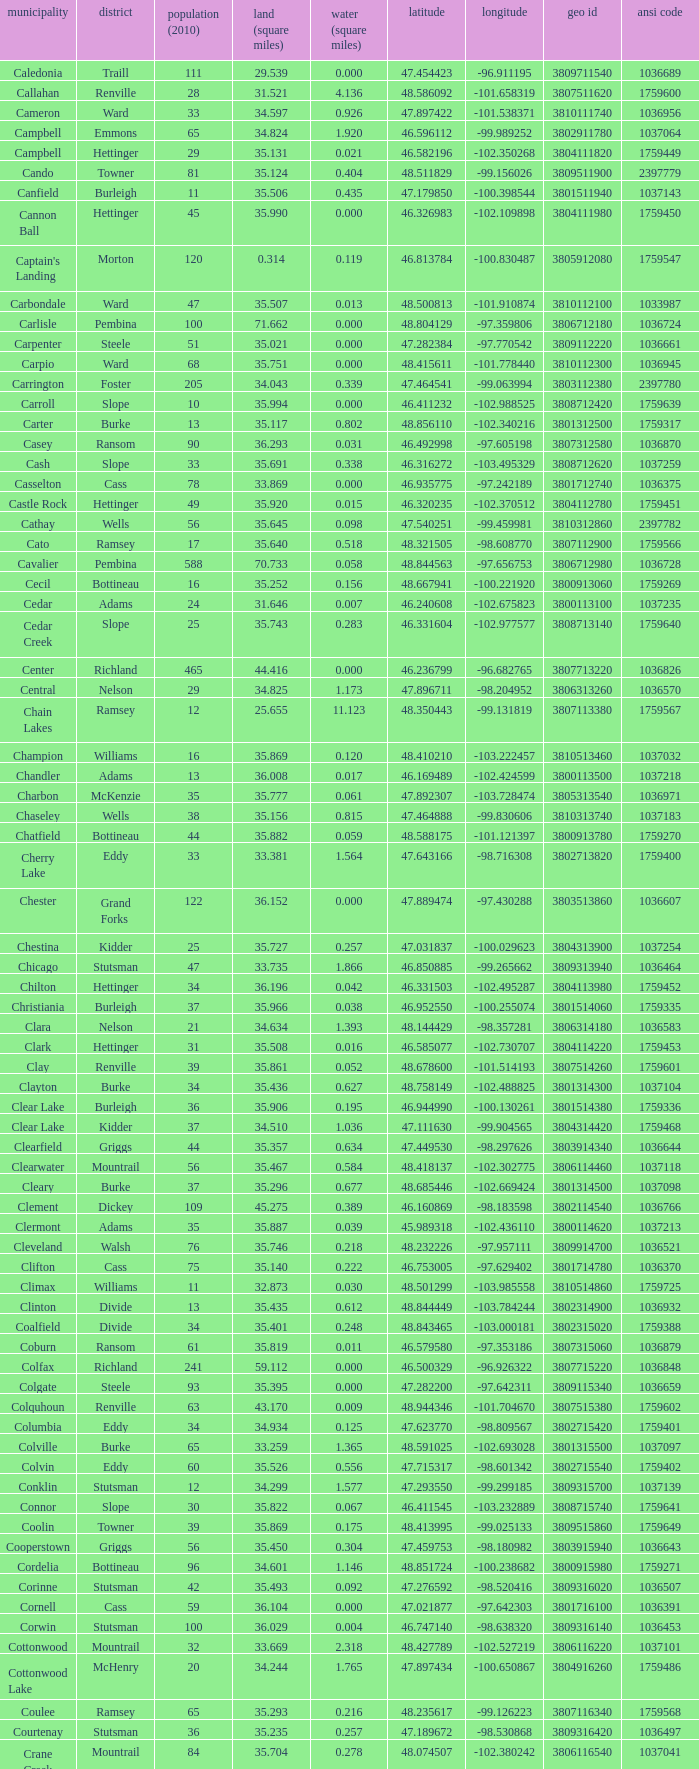What was the county with a latitude of 46.770977? Kidder. Could you parse the entire table? {'header': ['municipality', 'district', 'population (2010)', 'land (square miles)', 'water (square miles)', 'latitude', 'longitude', 'geo id', 'ansi code'], 'rows': [['Caledonia', 'Traill', '111', '29.539', '0.000', '47.454423', '-96.911195', '3809711540', '1036689'], ['Callahan', 'Renville', '28', '31.521', '4.136', '48.586092', '-101.658319', '3807511620', '1759600'], ['Cameron', 'Ward', '33', '34.597', '0.926', '47.897422', '-101.538371', '3810111740', '1036956'], ['Campbell', 'Emmons', '65', '34.824', '1.920', '46.596112', '-99.989252', '3802911780', '1037064'], ['Campbell', 'Hettinger', '29', '35.131', '0.021', '46.582196', '-102.350268', '3804111820', '1759449'], ['Cando', 'Towner', '81', '35.124', '0.404', '48.511829', '-99.156026', '3809511900', '2397779'], ['Canfield', 'Burleigh', '11', '35.506', '0.435', '47.179850', '-100.398544', '3801511940', '1037143'], ['Cannon Ball', 'Hettinger', '45', '35.990', '0.000', '46.326983', '-102.109898', '3804111980', '1759450'], ["Captain's Landing", 'Morton', '120', '0.314', '0.119', '46.813784', '-100.830487', '3805912080', '1759547'], ['Carbondale', 'Ward', '47', '35.507', '0.013', '48.500813', '-101.910874', '3810112100', '1033987'], ['Carlisle', 'Pembina', '100', '71.662', '0.000', '48.804129', '-97.359806', '3806712180', '1036724'], ['Carpenter', 'Steele', '51', '35.021', '0.000', '47.282384', '-97.770542', '3809112220', '1036661'], ['Carpio', 'Ward', '68', '35.751', '0.000', '48.415611', '-101.778440', '3810112300', '1036945'], ['Carrington', 'Foster', '205', '34.043', '0.339', '47.464541', '-99.063994', '3803112380', '2397780'], ['Carroll', 'Slope', '10', '35.994', '0.000', '46.411232', '-102.988525', '3808712420', '1759639'], ['Carter', 'Burke', '13', '35.117', '0.802', '48.856110', '-102.340216', '3801312500', '1759317'], ['Casey', 'Ransom', '90', '36.293', '0.031', '46.492998', '-97.605198', '3807312580', '1036870'], ['Cash', 'Slope', '33', '35.691', '0.338', '46.316272', '-103.495329', '3808712620', '1037259'], ['Casselton', 'Cass', '78', '33.869', '0.000', '46.935775', '-97.242189', '3801712740', '1036375'], ['Castle Rock', 'Hettinger', '49', '35.920', '0.015', '46.320235', '-102.370512', '3804112780', '1759451'], ['Cathay', 'Wells', '56', '35.645', '0.098', '47.540251', '-99.459981', '3810312860', '2397782'], ['Cato', 'Ramsey', '17', '35.640', '0.518', '48.321505', '-98.608770', '3807112900', '1759566'], ['Cavalier', 'Pembina', '588', '70.733', '0.058', '48.844563', '-97.656753', '3806712980', '1036728'], ['Cecil', 'Bottineau', '16', '35.252', '0.156', '48.667941', '-100.221920', '3800913060', '1759269'], ['Cedar', 'Adams', '24', '31.646', '0.007', '46.240608', '-102.675823', '3800113100', '1037235'], ['Cedar Creek', 'Slope', '25', '35.743', '0.283', '46.331604', '-102.977577', '3808713140', '1759640'], ['Center', 'Richland', '465', '44.416', '0.000', '46.236799', '-96.682765', '3807713220', '1036826'], ['Central', 'Nelson', '29', '34.825', '1.173', '47.896711', '-98.204952', '3806313260', '1036570'], ['Chain Lakes', 'Ramsey', '12', '25.655', '11.123', '48.350443', '-99.131819', '3807113380', '1759567'], ['Champion', 'Williams', '16', '35.869', '0.120', '48.410210', '-103.222457', '3810513460', '1037032'], ['Chandler', 'Adams', '13', '36.008', '0.017', '46.169489', '-102.424599', '3800113500', '1037218'], ['Charbon', 'McKenzie', '35', '35.777', '0.061', '47.892307', '-103.728474', '3805313540', '1036971'], ['Chaseley', 'Wells', '38', '35.156', '0.815', '47.464888', '-99.830606', '3810313740', '1037183'], ['Chatfield', 'Bottineau', '44', '35.882', '0.059', '48.588175', '-101.121397', '3800913780', '1759270'], ['Cherry Lake', 'Eddy', '33', '33.381', '1.564', '47.643166', '-98.716308', '3802713820', '1759400'], ['Chester', 'Grand Forks', '122', '36.152', '0.000', '47.889474', '-97.430288', '3803513860', '1036607'], ['Chestina', 'Kidder', '25', '35.727', '0.257', '47.031837', '-100.029623', '3804313900', '1037254'], ['Chicago', 'Stutsman', '47', '33.735', '1.866', '46.850885', '-99.265662', '3809313940', '1036464'], ['Chilton', 'Hettinger', '34', '36.196', '0.042', '46.331503', '-102.495287', '3804113980', '1759452'], ['Christiania', 'Burleigh', '37', '35.966', '0.038', '46.952550', '-100.255074', '3801514060', '1759335'], ['Clara', 'Nelson', '21', '34.634', '1.393', '48.144429', '-98.357281', '3806314180', '1036583'], ['Clark', 'Hettinger', '31', '35.508', '0.016', '46.585077', '-102.730707', '3804114220', '1759453'], ['Clay', 'Renville', '39', '35.861', '0.052', '48.678600', '-101.514193', '3807514260', '1759601'], ['Clayton', 'Burke', '34', '35.436', '0.627', '48.758149', '-102.488825', '3801314300', '1037104'], ['Clear Lake', 'Burleigh', '36', '35.906', '0.195', '46.944990', '-100.130261', '3801514380', '1759336'], ['Clear Lake', 'Kidder', '37', '34.510', '1.036', '47.111630', '-99.904565', '3804314420', '1759468'], ['Clearfield', 'Griggs', '44', '35.357', '0.634', '47.449530', '-98.297626', '3803914340', '1036644'], ['Clearwater', 'Mountrail', '56', '35.467', '0.584', '48.418137', '-102.302775', '3806114460', '1037118'], ['Cleary', 'Burke', '37', '35.296', '0.677', '48.685446', '-102.669424', '3801314500', '1037098'], ['Clement', 'Dickey', '109', '45.275', '0.389', '46.160869', '-98.183598', '3802114540', '1036766'], ['Clermont', 'Adams', '35', '35.887', '0.039', '45.989318', '-102.436110', '3800114620', '1037213'], ['Cleveland', 'Walsh', '76', '35.746', '0.218', '48.232226', '-97.957111', '3809914700', '1036521'], ['Clifton', 'Cass', '75', '35.140', '0.222', '46.753005', '-97.629402', '3801714780', '1036370'], ['Climax', 'Williams', '11', '32.873', '0.030', '48.501299', '-103.985558', '3810514860', '1759725'], ['Clinton', 'Divide', '13', '35.435', '0.612', '48.844449', '-103.784244', '3802314900', '1036932'], ['Coalfield', 'Divide', '34', '35.401', '0.248', '48.843465', '-103.000181', '3802315020', '1759388'], ['Coburn', 'Ransom', '61', '35.819', '0.011', '46.579580', '-97.353186', '3807315060', '1036879'], ['Colfax', 'Richland', '241', '59.112', '0.000', '46.500329', '-96.926322', '3807715220', '1036848'], ['Colgate', 'Steele', '93', '35.395', '0.000', '47.282200', '-97.642311', '3809115340', '1036659'], ['Colquhoun', 'Renville', '63', '43.170', '0.009', '48.944346', '-101.704670', '3807515380', '1759602'], ['Columbia', 'Eddy', '34', '34.934', '0.125', '47.623770', '-98.809567', '3802715420', '1759401'], ['Colville', 'Burke', '65', '33.259', '1.365', '48.591025', '-102.693028', '3801315500', '1037097'], ['Colvin', 'Eddy', '60', '35.526', '0.556', '47.715317', '-98.601342', '3802715540', '1759402'], ['Conklin', 'Stutsman', '12', '34.299', '1.577', '47.293550', '-99.299185', '3809315700', '1037139'], ['Connor', 'Slope', '30', '35.822', '0.067', '46.411545', '-103.232889', '3808715740', '1759641'], ['Coolin', 'Towner', '39', '35.869', '0.175', '48.413995', '-99.025133', '3809515860', '1759649'], ['Cooperstown', 'Griggs', '56', '35.450', '0.304', '47.459753', '-98.180982', '3803915940', '1036643'], ['Cordelia', 'Bottineau', '96', '34.601', '1.146', '48.851724', '-100.238682', '3800915980', '1759271'], ['Corinne', 'Stutsman', '42', '35.493', '0.092', '47.276592', '-98.520416', '3809316020', '1036507'], ['Cornell', 'Cass', '59', '36.104', '0.000', '47.021877', '-97.642303', '3801716100', '1036391'], ['Corwin', 'Stutsman', '100', '36.029', '0.004', '46.747140', '-98.638320', '3809316140', '1036453'], ['Cottonwood', 'Mountrail', '32', '33.669', '2.318', '48.427789', '-102.527219', '3806116220', '1037101'], ['Cottonwood Lake', 'McHenry', '20', '34.244', '1.765', '47.897434', '-100.650867', '3804916260', '1759486'], ['Coulee', 'Ramsey', '65', '35.293', '0.216', '48.235617', '-99.126223', '3807116340', '1759568'], ['Courtenay', 'Stutsman', '36', '35.235', '0.257', '47.189672', '-98.530868', '3809316420', '1036497'], ['Crane Creek', 'Mountrail', '84', '35.704', '0.278', '48.074507', '-102.380242', '3806116540', '1037041'], ['Crawford', 'Slope', '31', '35.892', '0.051', '46.320329', '-103.729934', '3808716620', '1037166'], ['Creel', 'Ramsey', '1305', '14.578', '15.621', '48.075823', '-98.857272', '3807116660', '1759569'], ['Cremerville', 'McLean', '27', '35.739', '0.054', '47.811011', '-102.054883', '3805516700', '1759530'], ['Crocus', 'Towner', '44', '35.047', '0.940', '48.667289', '-99.155787', '3809516820', '1759650'], ['Crofte', 'Burleigh', '199', '36.163', '0.000', '47.026425', '-100.685988', '3801516860', '1037131'], ['Cromwell', 'Burleigh', '35', '36.208', '0.000', '47.026008', '-100.558805', '3801516900', '1037133'], ['Crowfoot', 'Mountrail', '18', '34.701', '1.283', '48.495946', '-102.180433', '3806116980', '1037050'], ['Crown Hill', 'Kidder', '7', '30.799', '1.468', '46.770977', '-100.025924', '3804317020', '1759469'], ['Crystal', 'Pembina', '50', '35.499', '0.000', '48.586423', '-97.732145', '3806717100', '1036718'], ['Crystal Lake', 'Wells', '32', '35.522', '0.424', '47.541346', '-99.974737', '3810317140', '1037152'], ['Crystal Springs', 'Kidder', '32', '35.415', '0.636', '46.848792', '-99.529639', '3804317220', '1759470'], ['Cuba', 'Barnes', '76', '35.709', '0.032', '46.851144', '-97.860271', '3800317300', '1036409'], ['Cusator', 'Stutsman', '26', '34.878', '0.693', '46.746853', '-98.997611', '3809317460', '1036459'], ['Cut Bank', 'Bottineau', '37', '35.898', '0.033', '48.763937', '-101.430571', '3800917540', '1759272']]} 